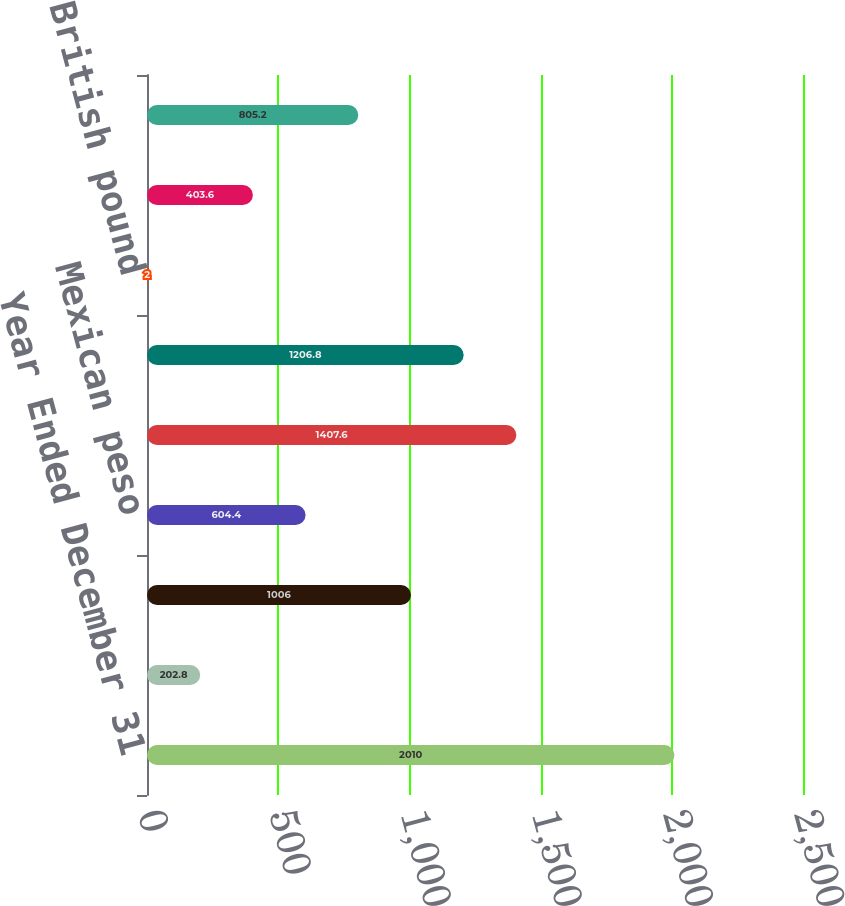Convert chart. <chart><loc_0><loc_0><loc_500><loc_500><bar_chart><fcel>Year Ended December 31<fcel>All operating currencies<fcel>Brazilian real<fcel>Mexican peso<fcel>Australian dollar<fcel>South African rand<fcel>British pound<fcel>Euro<fcel>Japanese yen<nl><fcel>2010<fcel>202.8<fcel>1006<fcel>604.4<fcel>1407.6<fcel>1206.8<fcel>2<fcel>403.6<fcel>805.2<nl></chart> 